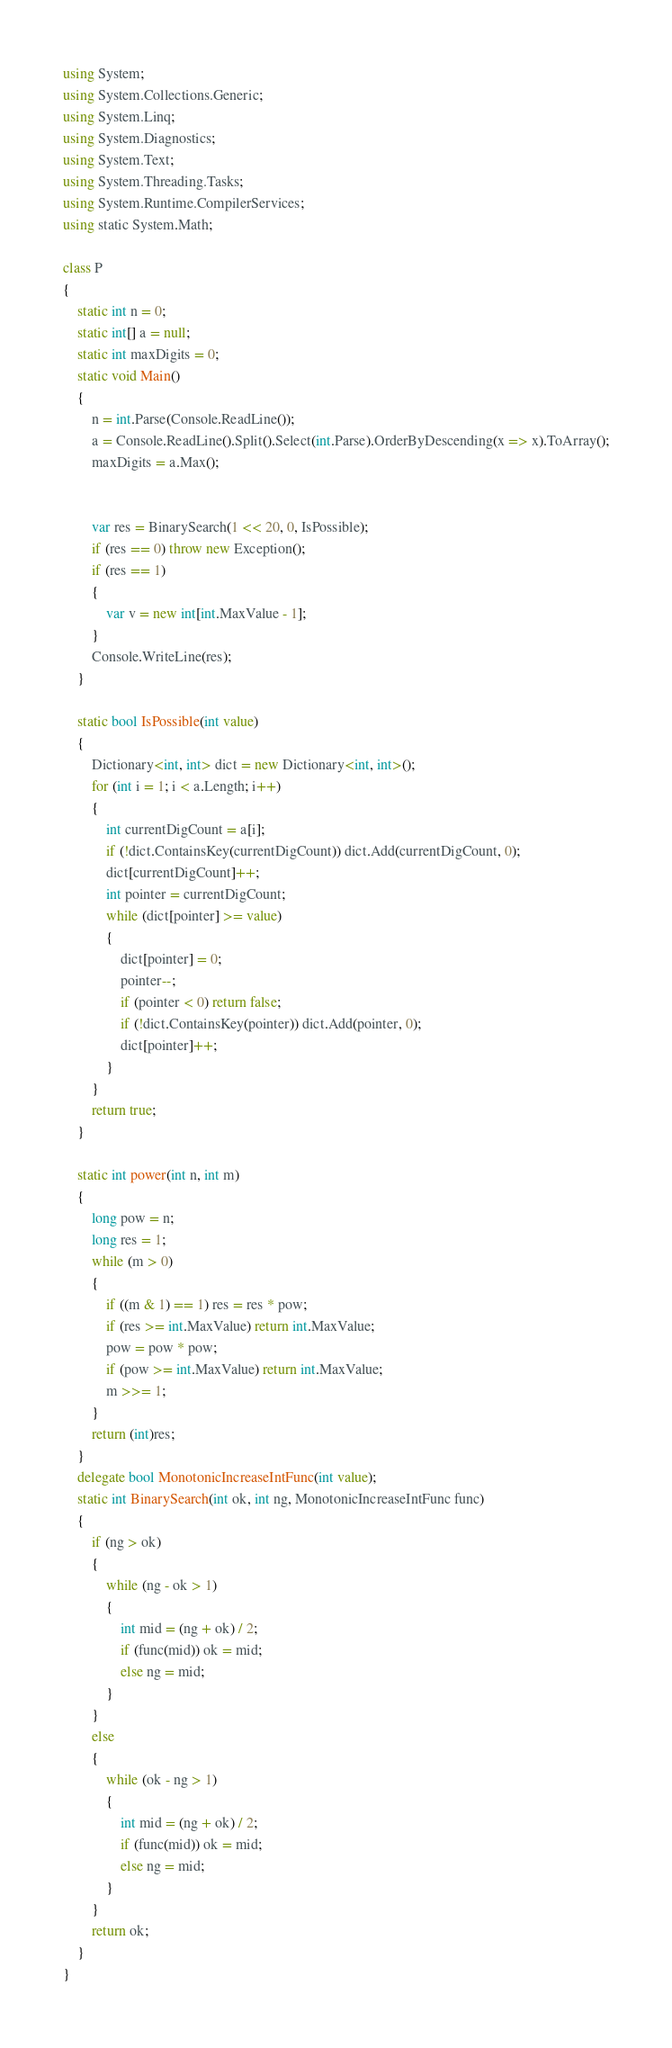Convert code to text. <code><loc_0><loc_0><loc_500><loc_500><_C#_>using System;
using System.Collections.Generic;
using System.Linq;
using System.Diagnostics;
using System.Text;
using System.Threading.Tasks;
using System.Runtime.CompilerServices;
using static System.Math;

class P
{
    static int n = 0;
    static int[] a = null;
    static int maxDigits = 0;
    static void Main()
    {
        n = int.Parse(Console.ReadLine());
        a = Console.ReadLine().Split().Select(int.Parse).OrderByDescending(x => x).ToArray();
        maxDigits = a.Max();

        
        var res = BinarySearch(1 << 20, 0, IsPossible);
        if (res == 0) throw new Exception();
        if (res == 1)
        {
            var v = new int[int.MaxValue - 1];
        }
        Console.WriteLine(res);
    }

    static bool IsPossible(int value)
    {
        Dictionary<int, int> dict = new Dictionary<int, int>();
        for (int i = 1; i < a.Length; i++)
        {
            int currentDigCount = a[i];
            if (!dict.ContainsKey(currentDigCount)) dict.Add(currentDigCount, 0);
            dict[currentDigCount]++;
            int pointer = currentDigCount;
            while (dict[pointer] >= value)
            {
                dict[pointer] = 0;
                pointer--;
                if (pointer < 0) return false;
                if (!dict.ContainsKey(pointer)) dict.Add(pointer, 0);
                dict[pointer]++;
            }
        }
        return true;
    }

    static int power(int n, int m)
    {
        long pow = n;
        long res = 1;
        while (m > 0)
        {
            if ((m & 1) == 1) res = res * pow;
            if (res >= int.MaxValue) return int.MaxValue;
            pow = pow * pow;
            if (pow >= int.MaxValue) return int.MaxValue;
            m >>= 1;
        }
        return (int)res;
    }
    delegate bool MonotonicIncreaseIntFunc(int value);
    static int BinarySearch(int ok, int ng, MonotonicIncreaseIntFunc func)
    {
        if (ng > ok)
        {
            while (ng - ok > 1)
            {
                int mid = (ng + ok) / 2;
                if (func(mid)) ok = mid;
                else ng = mid;
            }
        }
        else
        {
            while (ok - ng > 1)
            {
                int mid = (ng + ok) / 2;
                if (func(mid)) ok = mid;
                else ng = mid;
            }
        }
        return ok;
    }
}
</code> 